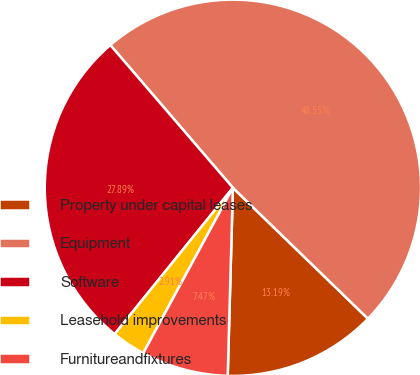<chart> <loc_0><loc_0><loc_500><loc_500><pie_chart><fcel>Property under capital leases<fcel>Equipment<fcel>Software<fcel>Leasehold improvements<fcel>Furnitureandfixtures<nl><fcel>13.19%<fcel>48.55%<fcel>27.89%<fcel>2.91%<fcel>7.47%<nl></chart> 